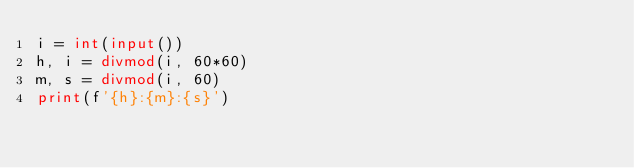<code> <loc_0><loc_0><loc_500><loc_500><_Python_>i = int(input())
h, i = divmod(i, 60*60)
m, s = divmod(i, 60)
print(f'{h}:{m}:{s}')

</code> 